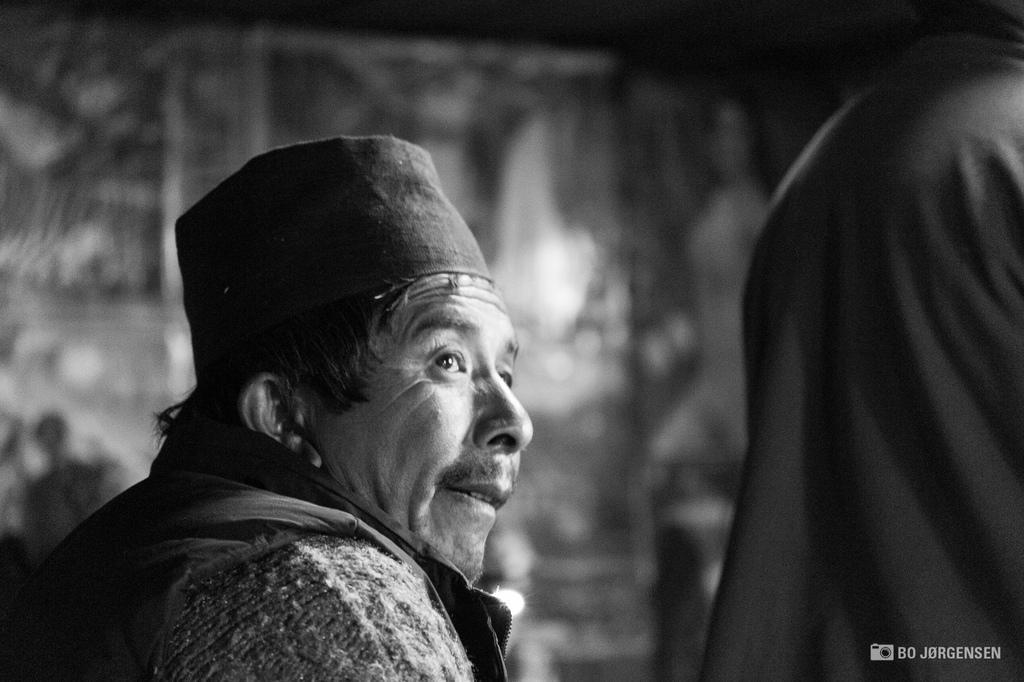Can you describe this image briefly? In this image, in the foreground there is an old person, and he is wearing, and he is wearing a hat. 